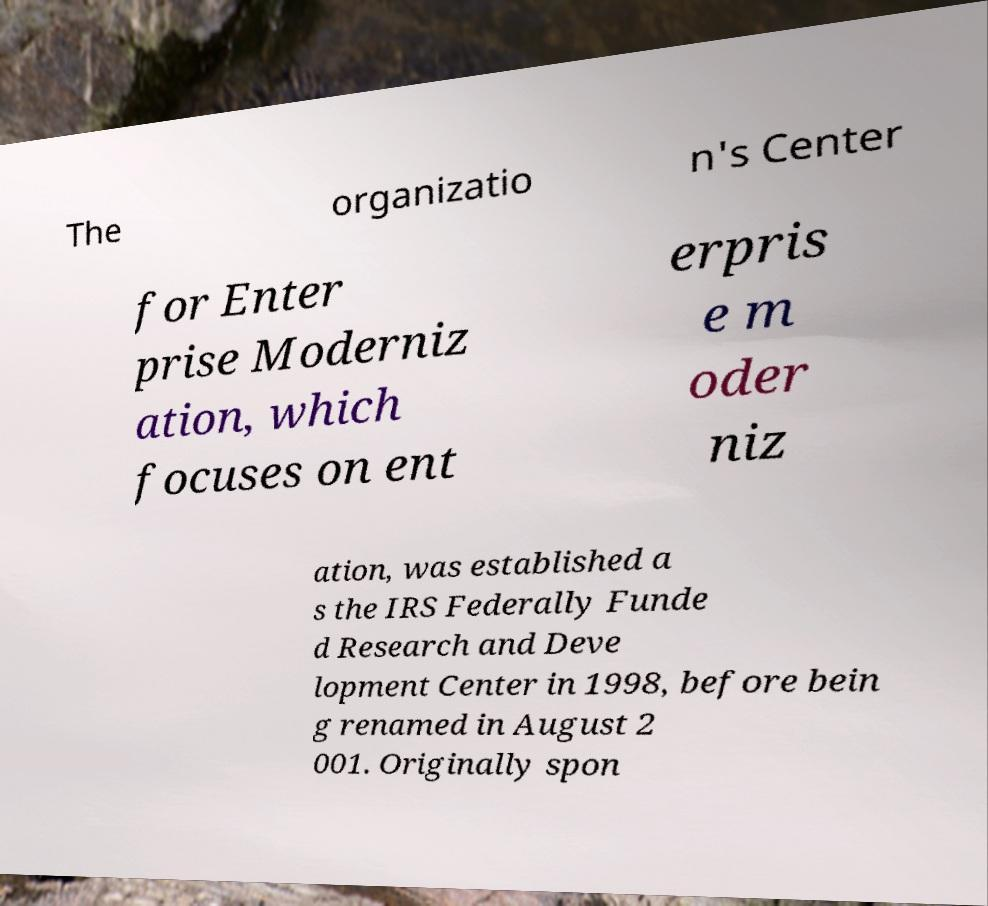Could you assist in decoding the text presented in this image and type it out clearly? The organizatio n's Center for Enter prise Moderniz ation, which focuses on ent erpris e m oder niz ation, was established a s the IRS Federally Funde d Research and Deve lopment Center in 1998, before bein g renamed in August 2 001. Originally spon 